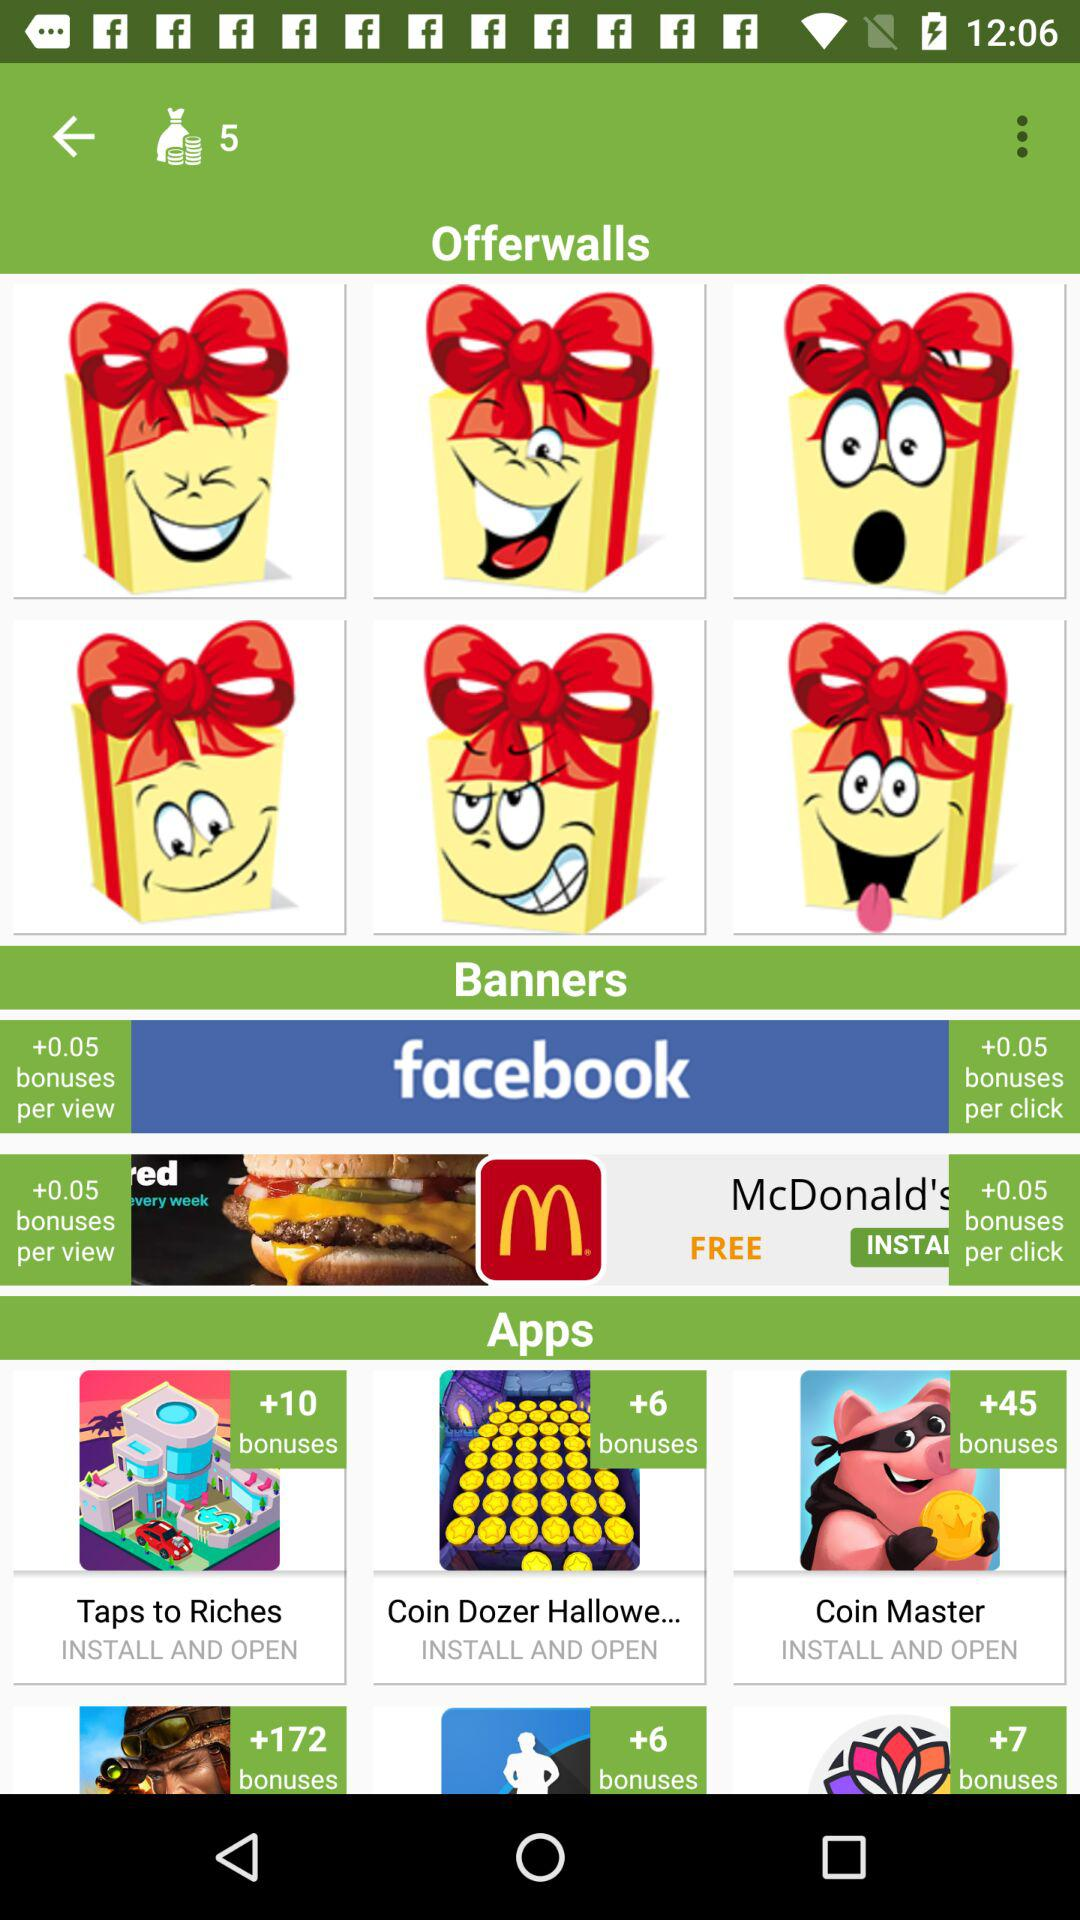What bonus will be offered per click on "facebook"? The bonus offered will be +0.05. 